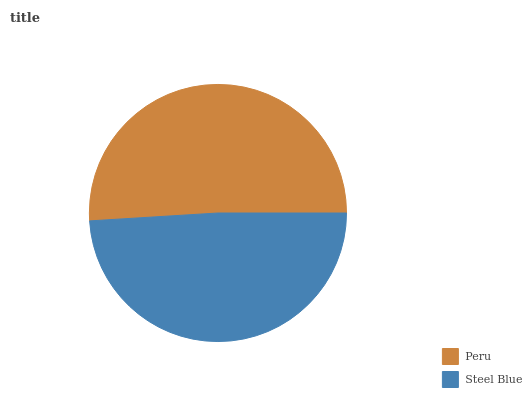Is Steel Blue the minimum?
Answer yes or no. Yes. Is Peru the maximum?
Answer yes or no. Yes. Is Steel Blue the maximum?
Answer yes or no. No. Is Peru greater than Steel Blue?
Answer yes or no. Yes. Is Steel Blue less than Peru?
Answer yes or no. Yes. Is Steel Blue greater than Peru?
Answer yes or no. No. Is Peru less than Steel Blue?
Answer yes or no. No. Is Peru the high median?
Answer yes or no. Yes. Is Steel Blue the low median?
Answer yes or no. Yes. Is Steel Blue the high median?
Answer yes or no. No. Is Peru the low median?
Answer yes or no. No. 